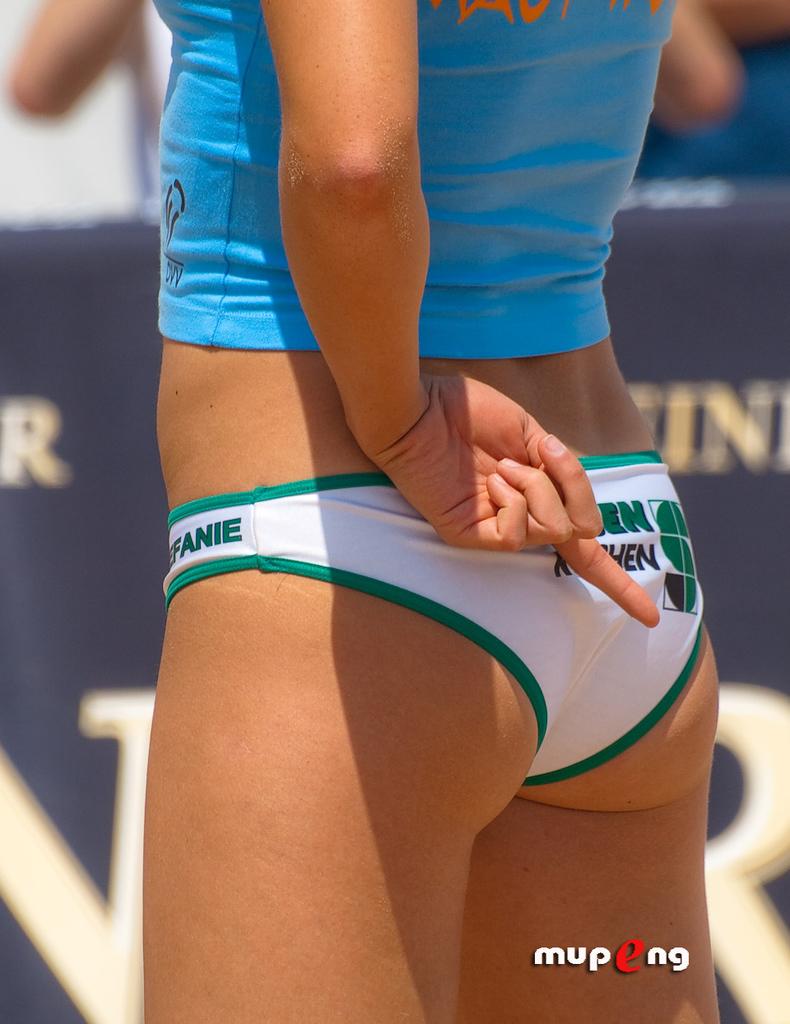What letters are visible on the side of the woman's shorts?
Offer a very short reply. Fanie. 